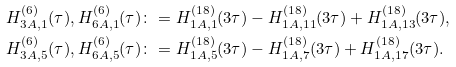Convert formula to latex. <formula><loc_0><loc_0><loc_500><loc_500>H ^ { ( 6 ) } _ { 3 A , 1 } ( \tau ) , H ^ { ( 6 ) } _ { 6 A , 1 } ( \tau ) & \colon = H ^ { ( 1 8 ) } _ { 1 A , 1 } ( 3 \tau ) - H ^ { ( 1 8 ) } _ { 1 A , 1 1 } ( 3 \tau ) + H ^ { ( 1 8 ) } _ { 1 A , 1 3 } ( 3 \tau ) , \\ H ^ { ( 6 ) } _ { 3 A , 5 } ( \tau ) , H ^ { ( 6 ) } _ { 6 A , 5 } ( \tau ) & \colon = H ^ { ( 1 8 ) } _ { 1 A , 5 } ( 3 \tau ) - H ^ { ( 1 8 ) } _ { 1 A , 7 } ( 3 \tau ) + H ^ { ( 1 8 ) } _ { 1 A , 1 7 } ( 3 \tau ) .</formula> 